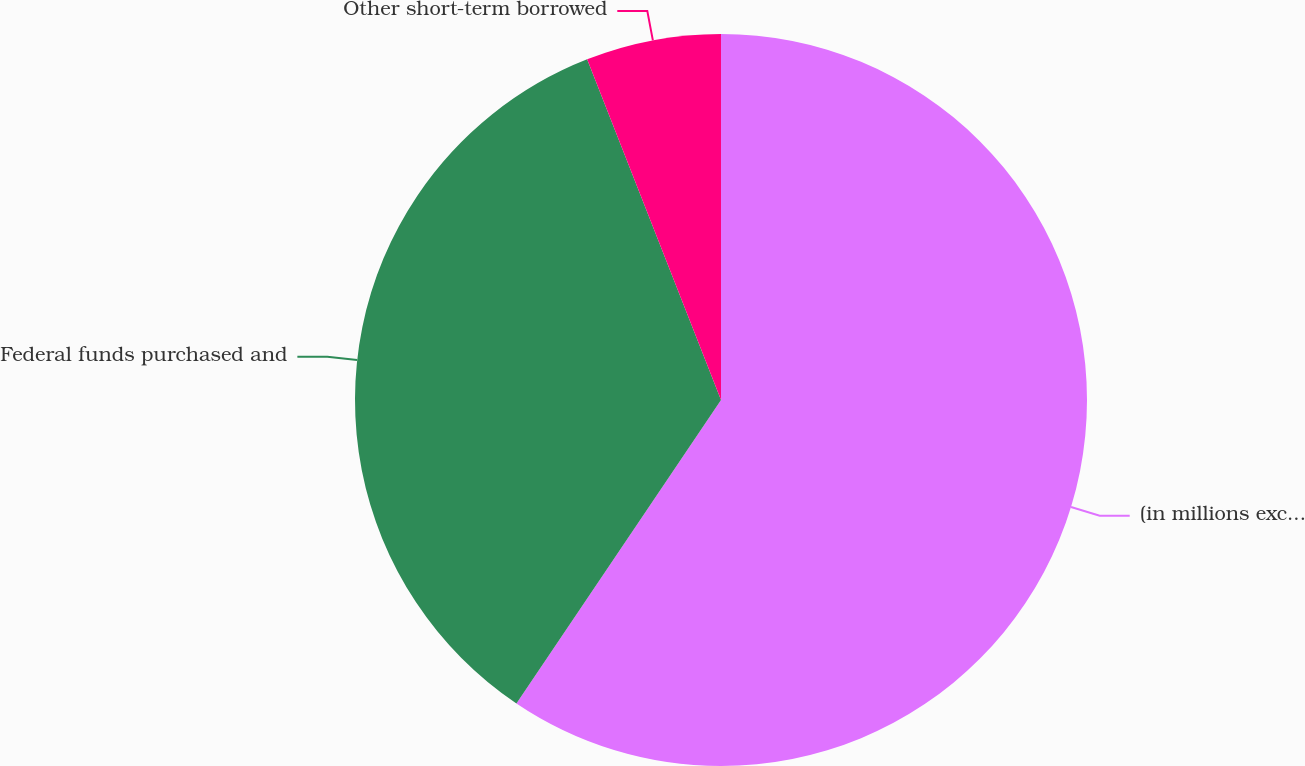Convert chart to OTSL. <chart><loc_0><loc_0><loc_500><loc_500><pie_chart><fcel>(in millions except ratio<fcel>Federal funds purchased and<fcel>Other short-term borrowed<nl><fcel>59.44%<fcel>34.6%<fcel>5.96%<nl></chart> 